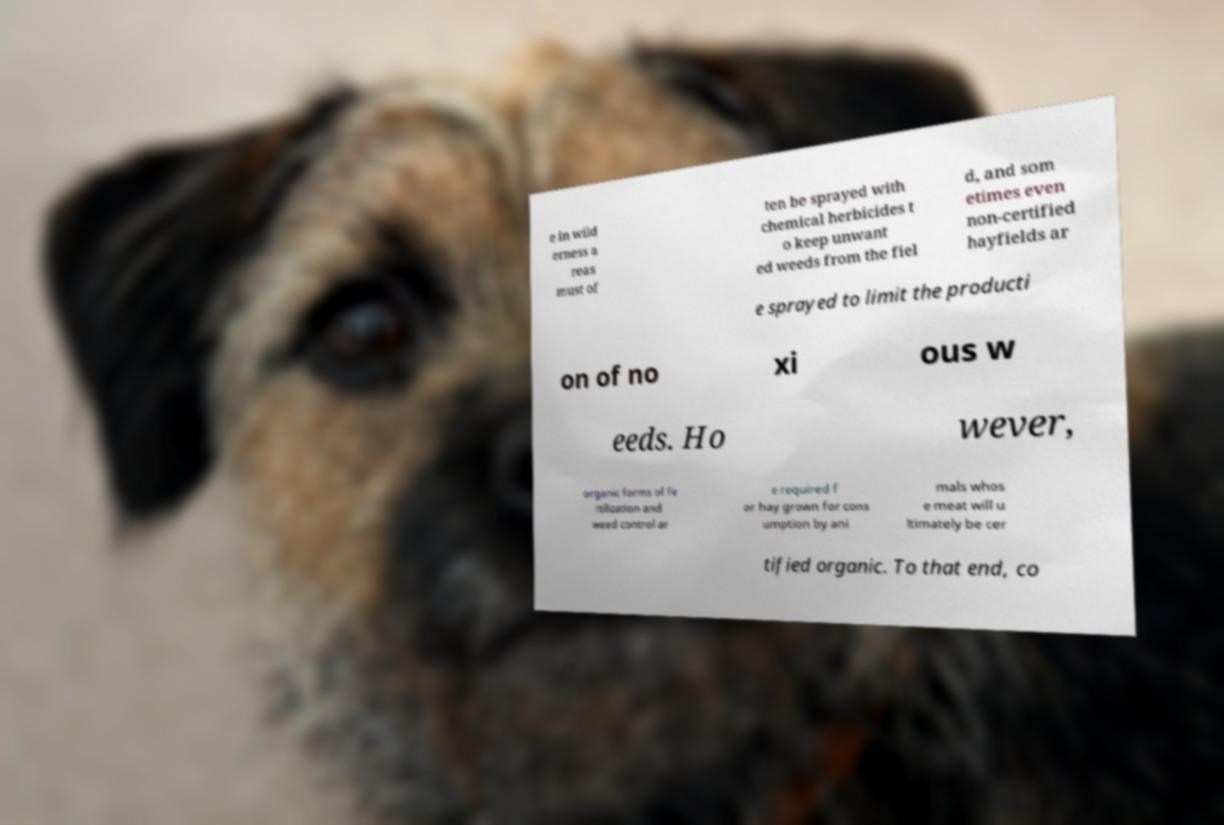I need the written content from this picture converted into text. Can you do that? e in wild erness a reas must of ten be sprayed with chemical herbicides t o keep unwant ed weeds from the fiel d, and som etimes even non-certified hayfields ar e sprayed to limit the producti on of no xi ous w eeds. Ho wever, organic forms of fe rtilization and weed control ar e required f or hay grown for cons umption by ani mals whos e meat will u ltimately be cer tified organic. To that end, co 